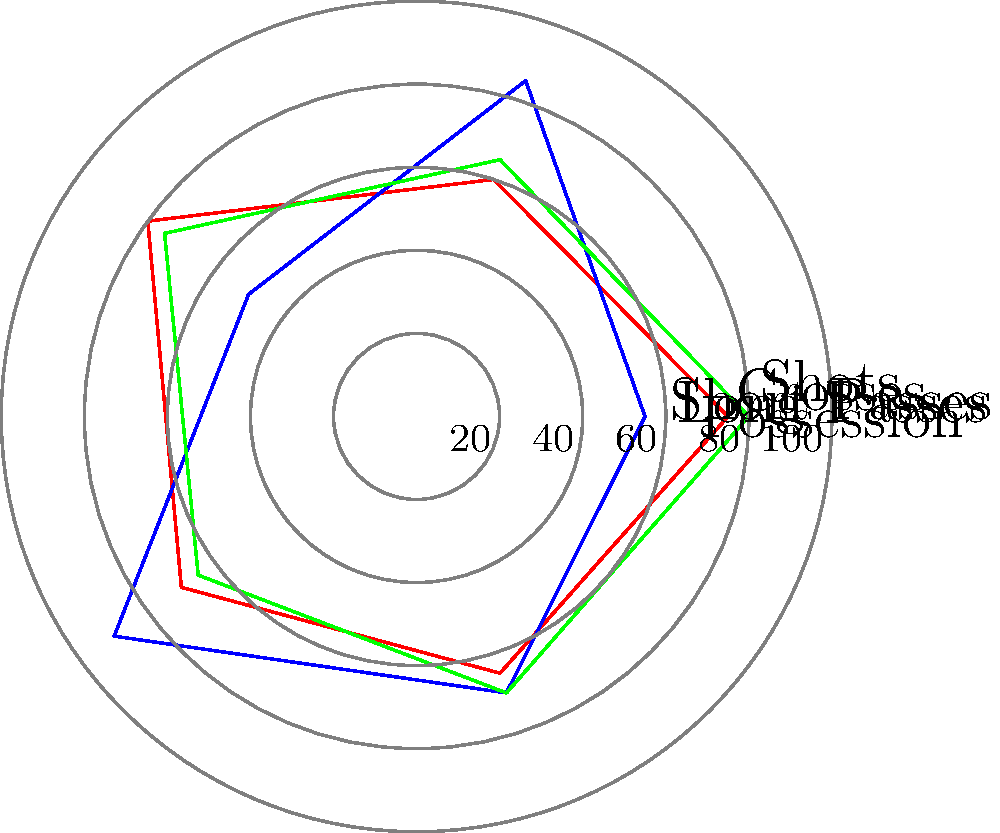Based on the radar chart showing the playing styles of three soccer teams, which two teams are most likely to be clustered together in a machine learning algorithm focusing on similar playing styles? To determine which two teams are most likely to be clustered together, we need to analyze their playing styles based on the five categories shown in the radar chart:

1. Possession: 
   Team A: 75, Team B: 55, Team C: 80

2. Long Passes:
   Team A: 60, Team B: 85, Team C: 65

3. Short Passes:
   Team A: 80, Team B: 50, Team C: 75

4. Crosses:
   Team A: 70, Team B: 90, Team C: 65

5. Shots:
   Team A: 65, Team B: 70, Team C: 70

Now, let's compare the teams:

1. Team A and Team C have similar values in most categories:
   - Both have high possession (75 vs 80)
   - Similar long passes (60 vs 65)
   - High short passes (80 vs 75)
   - Similar crosses (70 vs 65)
   - Similar shots (65 vs 70)

2. Team B has a distinctly different style:
   - Low possession (55)
   - Very high long passes (85)
   - Low short passes (50)
   - Very high crosses (90)

The overall shape of the radar chart for Team A and Team C is similar, while Team B's shape is noticeably different.

In a clustering algorithm, the distance between data points (teams in this case) would be calculated based on these features. The smaller the distance, the more likely the teams are to be clustered together.

Given the similarities in their playing styles, Team A and Team C would have a smaller distance between them compared to either team with Team B.
Answer: Team A and Team C 